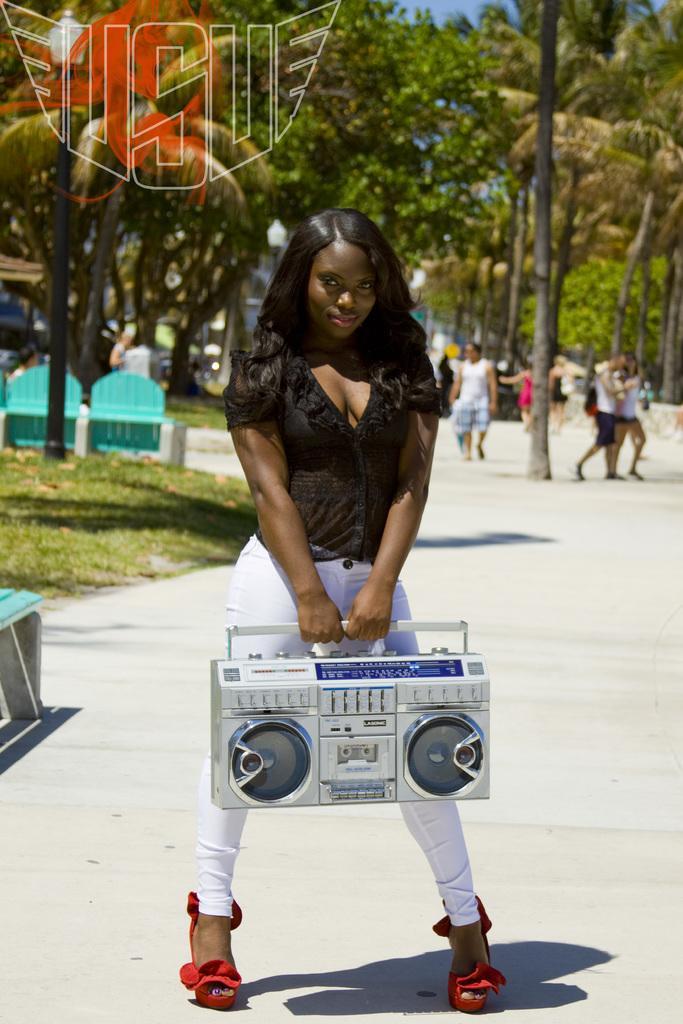Please provide a concise description of this image. In this picture in can see a woman holding a tape recorder in her hands and I can see few people walking and grass on the ground and a bench on the left side and I can see a watermark at the top left corner of the picture. 